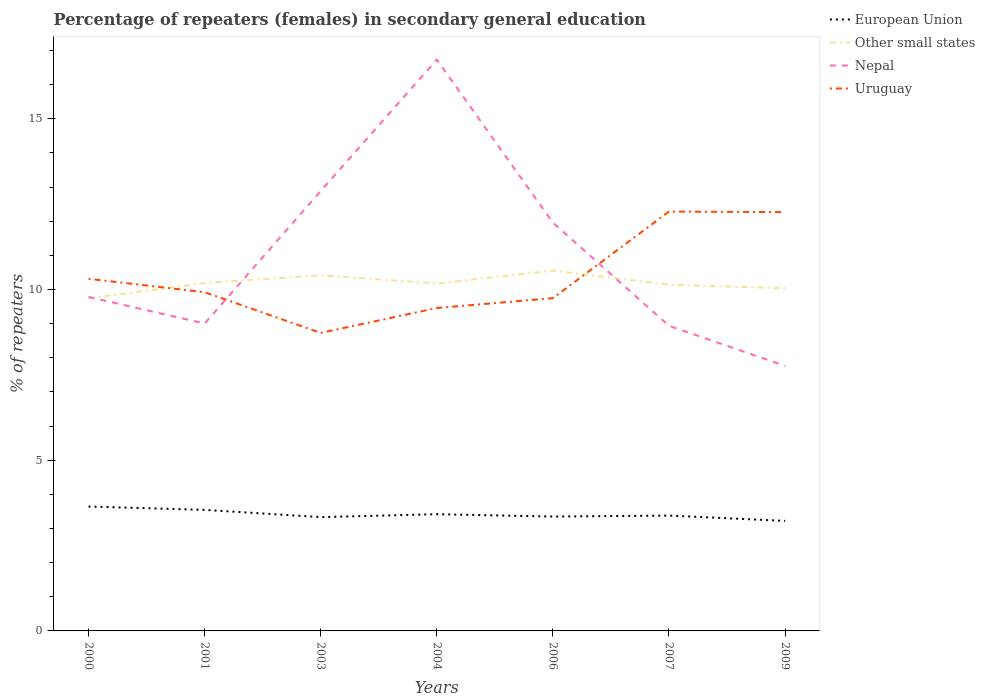Does the line corresponding to European Union intersect with the line corresponding to Nepal?
Make the answer very short. No. Across all years, what is the maximum percentage of female repeaters in European Union?
Offer a very short reply. 3.22. What is the total percentage of female repeaters in Other small states in the graph?
Your answer should be compact. 0.15. What is the difference between the highest and the second highest percentage of female repeaters in European Union?
Provide a short and direct response. 0.42. What is the difference between the highest and the lowest percentage of female repeaters in Uruguay?
Your response must be concise. 2. Is the percentage of female repeaters in Uruguay strictly greater than the percentage of female repeaters in Nepal over the years?
Make the answer very short. No. How many lines are there?
Give a very brief answer. 4. How many years are there in the graph?
Your response must be concise. 7. What is the difference between two consecutive major ticks on the Y-axis?
Give a very brief answer. 5. Are the values on the major ticks of Y-axis written in scientific E-notation?
Your answer should be very brief. No. Does the graph contain grids?
Offer a terse response. No. Where does the legend appear in the graph?
Ensure brevity in your answer.  Top right. How many legend labels are there?
Your response must be concise. 4. How are the legend labels stacked?
Your answer should be very brief. Vertical. What is the title of the graph?
Ensure brevity in your answer.  Percentage of repeaters (females) in secondary general education. Does "Czech Republic" appear as one of the legend labels in the graph?
Provide a short and direct response. No. What is the label or title of the X-axis?
Your answer should be compact. Years. What is the label or title of the Y-axis?
Your response must be concise. % of repeaters. What is the % of repeaters in European Union in 2000?
Make the answer very short. 3.64. What is the % of repeaters in Other small states in 2000?
Your answer should be very brief. 9.74. What is the % of repeaters of Nepal in 2000?
Make the answer very short. 9.78. What is the % of repeaters of Uruguay in 2000?
Offer a terse response. 10.31. What is the % of repeaters of European Union in 2001?
Your answer should be very brief. 3.55. What is the % of repeaters of Other small states in 2001?
Your answer should be very brief. 10.19. What is the % of repeaters in Nepal in 2001?
Your response must be concise. 9. What is the % of repeaters of Uruguay in 2001?
Your response must be concise. 9.92. What is the % of repeaters in European Union in 2003?
Give a very brief answer. 3.33. What is the % of repeaters in Other small states in 2003?
Offer a terse response. 10.42. What is the % of repeaters of Nepal in 2003?
Offer a terse response. 12.88. What is the % of repeaters in Uruguay in 2003?
Ensure brevity in your answer.  8.73. What is the % of repeaters of European Union in 2004?
Ensure brevity in your answer.  3.42. What is the % of repeaters of Other small states in 2004?
Give a very brief answer. 10.17. What is the % of repeaters of Nepal in 2004?
Offer a very short reply. 16.73. What is the % of repeaters in Uruguay in 2004?
Ensure brevity in your answer.  9.46. What is the % of repeaters in European Union in 2006?
Your answer should be compact. 3.35. What is the % of repeaters of Other small states in 2006?
Make the answer very short. 10.55. What is the % of repeaters of Nepal in 2006?
Your answer should be compact. 11.96. What is the % of repeaters in Uruguay in 2006?
Your response must be concise. 9.75. What is the % of repeaters of European Union in 2007?
Your response must be concise. 3.38. What is the % of repeaters of Other small states in 2007?
Make the answer very short. 10.14. What is the % of repeaters of Nepal in 2007?
Your response must be concise. 8.94. What is the % of repeaters of Uruguay in 2007?
Your answer should be very brief. 12.28. What is the % of repeaters of European Union in 2009?
Your answer should be very brief. 3.22. What is the % of repeaters in Other small states in 2009?
Keep it short and to the point. 10.03. What is the % of repeaters in Nepal in 2009?
Make the answer very short. 7.76. What is the % of repeaters of Uruguay in 2009?
Your response must be concise. 12.26. Across all years, what is the maximum % of repeaters in European Union?
Offer a terse response. 3.64. Across all years, what is the maximum % of repeaters in Other small states?
Offer a very short reply. 10.55. Across all years, what is the maximum % of repeaters in Nepal?
Give a very brief answer. 16.73. Across all years, what is the maximum % of repeaters in Uruguay?
Offer a terse response. 12.28. Across all years, what is the minimum % of repeaters of European Union?
Provide a succinct answer. 3.22. Across all years, what is the minimum % of repeaters in Other small states?
Provide a succinct answer. 9.74. Across all years, what is the minimum % of repeaters of Nepal?
Ensure brevity in your answer.  7.76. Across all years, what is the minimum % of repeaters in Uruguay?
Offer a terse response. 8.73. What is the total % of repeaters in European Union in the graph?
Ensure brevity in your answer.  23.89. What is the total % of repeaters in Other small states in the graph?
Offer a terse response. 71.24. What is the total % of repeaters of Nepal in the graph?
Make the answer very short. 77.05. What is the total % of repeaters of Uruguay in the graph?
Provide a succinct answer. 72.71. What is the difference between the % of repeaters in European Union in 2000 and that in 2001?
Offer a very short reply. 0.1. What is the difference between the % of repeaters in Other small states in 2000 and that in 2001?
Make the answer very short. -0.45. What is the difference between the % of repeaters of Nepal in 2000 and that in 2001?
Offer a terse response. 0.78. What is the difference between the % of repeaters of Uruguay in 2000 and that in 2001?
Keep it short and to the point. 0.39. What is the difference between the % of repeaters in European Union in 2000 and that in 2003?
Make the answer very short. 0.31. What is the difference between the % of repeaters of Other small states in 2000 and that in 2003?
Make the answer very short. -0.68. What is the difference between the % of repeaters of Nepal in 2000 and that in 2003?
Offer a very short reply. -3.1. What is the difference between the % of repeaters in Uruguay in 2000 and that in 2003?
Make the answer very short. 1.58. What is the difference between the % of repeaters of European Union in 2000 and that in 2004?
Offer a terse response. 0.22. What is the difference between the % of repeaters of Other small states in 2000 and that in 2004?
Keep it short and to the point. -0.43. What is the difference between the % of repeaters in Nepal in 2000 and that in 2004?
Give a very brief answer. -6.95. What is the difference between the % of repeaters of Uruguay in 2000 and that in 2004?
Give a very brief answer. 0.86. What is the difference between the % of repeaters in European Union in 2000 and that in 2006?
Your answer should be very brief. 0.29. What is the difference between the % of repeaters of Other small states in 2000 and that in 2006?
Offer a very short reply. -0.81. What is the difference between the % of repeaters in Nepal in 2000 and that in 2006?
Your answer should be compact. -2.17. What is the difference between the % of repeaters in Uruguay in 2000 and that in 2006?
Your response must be concise. 0.57. What is the difference between the % of repeaters of European Union in 2000 and that in 2007?
Provide a succinct answer. 0.26. What is the difference between the % of repeaters of Other small states in 2000 and that in 2007?
Give a very brief answer. -0.4. What is the difference between the % of repeaters of Nepal in 2000 and that in 2007?
Offer a very short reply. 0.85. What is the difference between the % of repeaters in Uruguay in 2000 and that in 2007?
Your response must be concise. -1.97. What is the difference between the % of repeaters in European Union in 2000 and that in 2009?
Offer a terse response. 0.42. What is the difference between the % of repeaters in Other small states in 2000 and that in 2009?
Keep it short and to the point. -0.3. What is the difference between the % of repeaters of Nepal in 2000 and that in 2009?
Give a very brief answer. 2.02. What is the difference between the % of repeaters of Uruguay in 2000 and that in 2009?
Your response must be concise. -1.95. What is the difference between the % of repeaters in European Union in 2001 and that in 2003?
Make the answer very short. 0.21. What is the difference between the % of repeaters in Other small states in 2001 and that in 2003?
Keep it short and to the point. -0.23. What is the difference between the % of repeaters in Nepal in 2001 and that in 2003?
Offer a very short reply. -3.88. What is the difference between the % of repeaters in Uruguay in 2001 and that in 2003?
Your answer should be very brief. 1.19. What is the difference between the % of repeaters of European Union in 2001 and that in 2004?
Keep it short and to the point. 0.13. What is the difference between the % of repeaters in Other small states in 2001 and that in 2004?
Your answer should be very brief. 0.02. What is the difference between the % of repeaters of Nepal in 2001 and that in 2004?
Provide a short and direct response. -7.73. What is the difference between the % of repeaters in Uruguay in 2001 and that in 2004?
Keep it short and to the point. 0.46. What is the difference between the % of repeaters in European Union in 2001 and that in 2006?
Make the answer very short. 0.2. What is the difference between the % of repeaters of Other small states in 2001 and that in 2006?
Offer a terse response. -0.36. What is the difference between the % of repeaters of Nepal in 2001 and that in 2006?
Make the answer very short. -2.95. What is the difference between the % of repeaters in Uruguay in 2001 and that in 2006?
Your answer should be compact. 0.17. What is the difference between the % of repeaters in European Union in 2001 and that in 2007?
Your answer should be very brief. 0.17. What is the difference between the % of repeaters of Other small states in 2001 and that in 2007?
Make the answer very short. 0.05. What is the difference between the % of repeaters of Nepal in 2001 and that in 2007?
Offer a terse response. 0.07. What is the difference between the % of repeaters of Uruguay in 2001 and that in 2007?
Ensure brevity in your answer.  -2.36. What is the difference between the % of repeaters in European Union in 2001 and that in 2009?
Make the answer very short. 0.32. What is the difference between the % of repeaters of Other small states in 2001 and that in 2009?
Give a very brief answer. 0.15. What is the difference between the % of repeaters of Nepal in 2001 and that in 2009?
Keep it short and to the point. 1.24. What is the difference between the % of repeaters in Uruguay in 2001 and that in 2009?
Offer a very short reply. -2.35. What is the difference between the % of repeaters of European Union in 2003 and that in 2004?
Keep it short and to the point. -0.09. What is the difference between the % of repeaters of Other small states in 2003 and that in 2004?
Make the answer very short. 0.24. What is the difference between the % of repeaters of Nepal in 2003 and that in 2004?
Give a very brief answer. -3.85. What is the difference between the % of repeaters of Uruguay in 2003 and that in 2004?
Provide a short and direct response. -0.73. What is the difference between the % of repeaters in European Union in 2003 and that in 2006?
Your answer should be compact. -0.02. What is the difference between the % of repeaters in Other small states in 2003 and that in 2006?
Give a very brief answer. -0.14. What is the difference between the % of repeaters in Nepal in 2003 and that in 2006?
Provide a short and direct response. 0.93. What is the difference between the % of repeaters of Uruguay in 2003 and that in 2006?
Offer a very short reply. -1.02. What is the difference between the % of repeaters of European Union in 2003 and that in 2007?
Make the answer very short. -0.05. What is the difference between the % of repeaters of Other small states in 2003 and that in 2007?
Provide a short and direct response. 0.27. What is the difference between the % of repeaters in Nepal in 2003 and that in 2007?
Offer a very short reply. 3.95. What is the difference between the % of repeaters of Uruguay in 2003 and that in 2007?
Make the answer very short. -3.55. What is the difference between the % of repeaters of European Union in 2003 and that in 2009?
Make the answer very short. 0.11. What is the difference between the % of repeaters in Other small states in 2003 and that in 2009?
Your answer should be very brief. 0.38. What is the difference between the % of repeaters of Nepal in 2003 and that in 2009?
Provide a short and direct response. 5.12. What is the difference between the % of repeaters of Uruguay in 2003 and that in 2009?
Ensure brevity in your answer.  -3.54. What is the difference between the % of repeaters of European Union in 2004 and that in 2006?
Your answer should be compact. 0.07. What is the difference between the % of repeaters in Other small states in 2004 and that in 2006?
Your answer should be compact. -0.38. What is the difference between the % of repeaters in Nepal in 2004 and that in 2006?
Your response must be concise. 4.77. What is the difference between the % of repeaters in Uruguay in 2004 and that in 2006?
Your response must be concise. -0.29. What is the difference between the % of repeaters in European Union in 2004 and that in 2007?
Your answer should be compact. 0.04. What is the difference between the % of repeaters of Other small states in 2004 and that in 2007?
Provide a succinct answer. 0.03. What is the difference between the % of repeaters of Nepal in 2004 and that in 2007?
Ensure brevity in your answer.  7.8. What is the difference between the % of repeaters in Uruguay in 2004 and that in 2007?
Your response must be concise. -2.83. What is the difference between the % of repeaters of European Union in 2004 and that in 2009?
Keep it short and to the point. 0.2. What is the difference between the % of repeaters of Other small states in 2004 and that in 2009?
Offer a terse response. 0.14. What is the difference between the % of repeaters in Nepal in 2004 and that in 2009?
Offer a terse response. 8.97. What is the difference between the % of repeaters of Uruguay in 2004 and that in 2009?
Your answer should be compact. -2.81. What is the difference between the % of repeaters of European Union in 2006 and that in 2007?
Your answer should be compact. -0.03. What is the difference between the % of repeaters in Other small states in 2006 and that in 2007?
Offer a terse response. 0.41. What is the difference between the % of repeaters in Nepal in 2006 and that in 2007?
Your response must be concise. 3.02. What is the difference between the % of repeaters of Uruguay in 2006 and that in 2007?
Your answer should be very brief. -2.54. What is the difference between the % of repeaters of European Union in 2006 and that in 2009?
Your answer should be compact. 0.13. What is the difference between the % of repeaters in Other small states in 2006 and that in 2009?
Provide a succinct answer. 0.52. What is the difference between the % of repeaters in Nepal in 2006 and that in 2009?
Make the answer very short. 4.2. What is the difference between the % of repeaters of Uruguay in 2006 and that in 2009?
Provide a short and direct response. -2.52. What is the difference between the % of repeaters of European Union in 2007 and that in 2009?
Provide a short and direct response. 0.16. What is the difference between the % of repeaters in Other small states in 2007 and that in 2009?
Keep it short and to the point. 0.11. What is the difference between the % of repeaters of Nepal in 2007 and that in 2009?
Give a very brief answer. 1.17. What is the difference between the % of repeaters of Uruguay in 2007 and that in 2009?
Offer a very short reply. 0.02. What is the difference between the % of repeaters in European Union in 2000 and the % of repeaters in Other small states in 2001?
Offer a very short reply. -6.55. What is the difference between the % of repeaters in European Union in 2000 and the % of repeaters in Nepal in 2001?
Offer a terse response. -5.36. What is the difference between the % of repeaters in European Union in 2000 and the % of repeaters in Uruguay in 2001?
Your answer should be very brief. -6.28. What is the difference between the % of repeaters of Other small states in 2000 and the % of repeaters of Nepal in 2001?
Keep it short and to the point. 0.74. What is the difference between the % of repeaters in Other small states in 2000 and the % of repeaters in Uruguay in 2001?
Offer a very short reply. -0.18. What is the difference between the % of repeaters in Nepal in 2000 and the % of repeaters in Uruguay in 2001?
Keep it short and to the point. -0.14. What is the difference between the % of repeaters of European Union in 2000 and the % of repeaters of Other small states in 2003?
Offer a terse response. -6.77. What is the difference between the % of repeaters in European Union in 2000 and the % of repeaters in Nepal in 2003?
Your response must be concise. -9.24. What is the difference between the % of repeaters in European Union in 2000 and the % of repeaters in Uruguay in 2003?
Ensure brevity in your answer.  -5.09. What is the difference between the % of repeaters in Other small states in 2000 and the % of repeaters in Nepal in 2003?
Give a very brief answer. -3.15. What is the difference between the % of repeaters of Other small states in 2000 and the % of repeaters of Uruguay in 2003?
Offer a terse response. 1.01. What is the difference between the % of repeaters in Nepal in 2000 and the % of repeaters in Uruguay in 2003?
Offer a terse response. 1.05. What is the difference between the % of repeaters in European Union in 2000 and the % of repeaters in Other small states in 2004?
Your response must be concise. -6.53. What is the difference between the % of repeaters in European Union in 2000 and the % of repeaters in Nepal in 2004?
Offer a terse response. -13.09. What is the difference between the % of repeaters of European Union in 2000 and the % of repeaters of Uruguay in 2004?
Your answer should be compact. -5.81. What is the difference between the % of repeaters in Other small states in 2000 and the % of repeaters in Nepal in 2004?
Offer a very short reply. -6.99. What is the difference between the % of repeaters of Other small states in 2000 and the % of repeaters of Uruguay in 2004?
Ensure brevity in your answer.  0.28. What is the difference between the % of repeaters of Nepal in 2000 and the % of repeaters of Uruguay in 2004?
Make the answer very short. 0.33. What is the difference between the % of repeaters of European Union in 2000 and the % of repeaters of Other small states in 2006?
Make the answer very short. -6.91. What is the difference between the % of repeaters of European Union in 2000 and the % of repeaters of Nepal in 2006?
Keep it short and to the point. -8.31. What is the difference between the % of repeaters in European Union in 2000 and the % of repeaters in Uruguay in 2006?
Your answer should be compact. -6.1. What is the difference between the % of repeaters in Other small states in 2000 and the % of repeaters in Nepal in 2006?
Offer a very short reply. -2.22. What is the difference between the % of repeaters of Other small states in 2000 and the % of repeaters of Uruguay in 2006?
Keep it short and to the point. -0.01. What is the difference between the % of repeaters in Nepal in 2000 and the % of repeaters in Uruguay in 2006?
Your response must be concise. 0.04. What is the difference between the % of repeaters of European Union in 2000 and the % of repeaters of Other small states in 2007?
Your answer should be compact. -6.5. What is the difference between the % of repeaters in European Union in 2000 and the % of repeaters in Nepal in 2007?
Keep it short and to the point. -5.29. What is the difference between the % of repeaters in European Union in 2000 and the % of repeaters in Uruguay in 2007?
Your response must be concise. -8.64. What is the difference between the % of repeaters of Other small states in 2000 and the % of repeaters of Nepal in 2007?
Provide a short and direct response. 0.8. What is the difference between the % of repeaters of Other small states in 2000 and the % of repeaters of Uruguay in 2007?
Make the answer very short. -2.54. What is the difference between the % of repeaters in Nepal in 2000 and the % of repeaters in Uruguay in 2007?
Give a very brief answer. -2.5. What is the difference between the % of repeaters of European Union in 2000 and the % of repeaters of Other small states in 2009?
Your answer should be compact. -6.39. What is the difference between the % of repeaters in European Union in 2000 and the % of repeaters in Nepal in 2009?
Give a very brief answer. -4.12. What is the difference between the % of repeaters in European Union in 2000 and the % of repeaters in Uruguay in 2009?
Keep it short and to the point. -8.62. What is the difference between the % of repeaters of Other small states in 2000 and the % of repeaters of Nepal in 2009?
Ensure brevity in your answer.  1.98. What is the difference between the % of repeaters in Other small states in 2000 and the % of repeaters in Uruguay in 2009?
Give a very brief answer. -2.53. What is the difference between the % of repeaters of Nepal in 2000 and the % of repeaters of Uruguay in 2009?
Provide a succinct answer. -2.48. What is the difference between the % of repeaters in European Union in 2001 and the % of repeaters in Other small states in 2003?
Offer a terse response. -6.87. What is the difference between the % of repeaters in European Union in 2001 and the % of repeaters in Nepal in 2003?
Provide a succinct answer. -9.34. What is the difference between the % of repeaters of European Union in 2001 and the % of repeaters of Uruguay in 2003?
Make the answer very short. -5.18. What is the difference between the % of repeaters of Other small states in 2001 and the % of repeaters of Nepal in 2003?
Your response must be concise. -2.7. What is the difference between the % of repeaters in Other small states in 2001 and the % of repeaters in Uruguay in 2003?
Keep it short and to the point. 1.46. What is the difference between the % of repeaters of Nepal in 2001 and the % of repeaters of Uruguay in 2003?
Offer a very short reply. 0.27. What is the difference between the % of repeaters of European Union in 2001 and the % of repeaters of Other small states in 2004?
Your response must be concise. -6.63. What is the difference between the % of repeaters in European Union in 2001 and the % of repeaters in Nepal in 2004?
Make the answer very short. -13.19. What is the difference between the % of repeaters of European Union in 2001 and the % of repeaters of Uruguay in 2004?
Give a very brief answer. -5.91. What is the difference between the % of repeaters in Other small states in 2001 and the % of repeaters in Nepal in 2004?
Provide a succinct answer. -6.54. What is the difference between the % of repeaters of Other small states in 2001 and the % of repeaters of Uruguay in 2004?
Your response must be concise. 0.73. What is the difference between the % of repeaters in Nepal in 2001 and the % of repeaters in Uruguay in 2004?
Offer a very short reply. -0.45. What is the difference between the % of repeaters in European Union in 2001 and the % of repeaters in Other small states in 2006?
Your answer should be very brief. -7.01. What is the difference between the % of repeaters in European Union in 2001 and the % of repeaters in Nepal in 2006?
Provide a succinct answer. -8.41. What is the difference between the % of repeaters in European Union in 2001 and the % of repeaters in Uruguay in 2006?
Ensure brevity in your answer.  -6.2. What is the difference between the % of repeaters of Other small states in 2001 and the % of repeaters of Nepal in 2006?
Keep it short and to the point. -1.77. What is the difference between the % of repeaters of Other small states in 2001 and the % of repeaters of Uruguay in 2006?
Your answer should be very brief. 0.44. What is the difference between the % of repeaters of Nepal in 2001 and the % of repeaters of Uruguay in 2006?
Keep it short and to the point. -0.74. What is the difference between the % of repeaters in European Union in 2001 and the % of repeaters in Other small states in 2007?
Provide a short and direct response. -6.6. What is the difference between the % of repeaters in European Union in 2001 and the % of repeaters in Nepal in 2007?
Ensure brevity in your answer.  -5.39. What is the difference between the % of repeaters of European Union in 2001 and the % of repeaters of Uruguay in 2007?
Your response must be concise. -8.74. What is the difference between the % of repeaters of Other small states in 2001 and the % of repeaters of Nepal in 2007?
Offer a very short reply. 1.25. What is the difference between the % of repeaters of Other small states in 2001 and the % of repeaters of Uruguay in 2007?
Your answer should be compact. -2.09. What is the difference between the % of repeaters in Nepal in 2001 and the % of repeaters in Uruguay in 2007?
Your answer should be very brief. -3.28. What is the difference between the % of repeaters of European Union in 2001 and the % of repeaters of Other small states in 2009?
Ensure brevity in your answer.  -6.49. What is the difference between the % of repeaters in European Union in 2001 and the % of repeaters in Nepal in 2009?
Your answer should be compact. -4.22. What is the difference between the % of repeaters in European Union in 2001 and the % of repeaters in Uruguay in 2009?
Ensure brevity in your answer.  -8.72. What is the difference between the % of repeaters of Other small states in 2001 and the % of repeaters of Nepal in 2009?
Provide a short and direct response. 2.43. What is the difference between the % of repeaters of Other small states in 2001 and the % of repeaters of Uruguay in 2009?
Keep it short and to the point. -2.08. What is the difference between the % of repeaters of Nepal in 2001 and the % of repeaters of Uruguay in 2009?
Offer a terse response. -3.26. What is the difference between the % of repeaters in European Union in 2003 and the % of repeaters in Other small states in 2004?
Your answer should be very brief. -6.84. What is the difference between the % of repeaters of European Union in 2003 and the % of repeaters of Nepal in 2004?
Give a very brief answer. -13.4. What is the difference between the % of repeaters of European Union in 2003 and the % of repeaters of Uruguay in 2004?
Give a very brief answer. -6.12. What is the difference between the % of repeaters in Other small states in 2003 and the % of repeaters in Nepal in 2004?
Provide a succinct answer. -6.32. What is the difference between the % of repeaters of Other small states in 2003 and the % of repeaters of Uruguay in 2004?
Offer a very short reply. 0.96. What is the difference between the % of repeaters of Nepal in 2003 and the % of repeaters of Uruguay in 2004?
Your answer should be very brief. 3.43. What is the difference between the % of repeaters in European Union in 2003 and the % of repeaters in Other small states in 2006?
Your answer should be very brief. -7.22. What is the difference between the % of repeaters in European Union in 2003 and the % of repeaters in Nepal in 2006?
Your answer should be very brief. -8.62. What is the difference between the % of repeaters in European Union in 2003 and the % of repeaters in Uruguay in 2006?
Ensure brevity in your answer.  -6.41. What is the difference between the % of repeaters in Other small states in 2003 and the % of repeaters in Nepal in 2006?
Your answer should be very brief. -1.54. What is the difference between the % of repeaters of Other small states in 2003 and the % of repeaters of Uruguay in 2006?
Your response must be concise. 0.67. What is the difference between the % of repeaters in Nepal in 2003 and the % of repeaters in Uruguay in 2006?
Your answer should be compact. 3.14. What is the difference between the % of repeaters in European Union in 2003 and the % of repeaters in Other small states in 2007?
Your response must be concise. -6.81. What is the difference between the % of repeaters in European Union in 2003 and the % of repeaters in Nepal in 2007?
Offer a terse response. -5.6. What is the difference between the % of repeaters in European Union in 2003 and the % of repeaters in Uruguay in 2007?
Keep it short and to the point. -8.95. What is the difference between the % of repeaters in Other small states in 2003 and the % of repeaters in Nepal in 2007?
Provide a short and direct response. 1.48. What is the difference between the % of repeaters in Other small states in 2003 and the % of repeaters in Uruguay in 2007?
Keep it short and to the point. -1.87. What is the difference between the % of repeaters of Nepal in 2003 and the % of repeaters of Uruguay in 2007?
Your answer should be compact. 0.6. What is the difference between the % of repeaters in European Union in 2003 and the % of repeaters in Other small states in 2009?
Your answer should be very brief. -6.7. What is the difference between the % of repeaters in European Union in 2003 and the % of repeaters in Nepal in 2009?
Offer a terse response. -4.43. What is the difference between the % of repeaters in European Union in 2003 and the % of repeaters in Uruguay in 2009?
Ensure brevity in your answer.  -8.93. What is the difference between the % of repeaters of Other small states in 2003 and the % of repeaters of Nepal in 2009?
Offer a terse response. 2.65. What is the difference between the % of repeaters of Other small states in 2003 and the % of repeaters of Uruguay in 2009?
Make the answer very short. -1.85. What is the difference between the % of repeaters of Nepal in 2003 and the % of repeaters of Uruguay in 2009?
Ensure brevity in your answer.  0.62. What is the difference between the % of repeaters in European Union in 2004 and the % of repeaters in Other small states in 2006?
Provide a short and direct response. -7.13. What is the difference between the % of repeaters of European Union in 2004 and the % of repeaters of Nepal in 2006?
Your answer should be compact. -8.54. What is the difference between the % of repeaters in European Union in 2004 and the % of repeaters in Uruguay in 2006?
Provide a succinct answer. -6.33. What is the difference between the % of repeaters in Other small states in 2004 and the % of repeaters in Nepal in 2006?
Make the answer very short. -1.78. What is the difference between the % of repeaters in Other small states in 2004 and the % of repeaters in Uruguay in 2006?
Make the answer very short. 0.43. What is the difference between the % of repeaters of Nepal in 2004 and the % of repeaters of Uruguay in 2006?
Your answer should be compact. 6.99. What is the difference between the % of repeaters in European Union in 2004 and the % of repeaters in Other small states in 2007?
Offer a terse response. -6.72. What is the difference between the % of repeaters in European Union in 2004 and the % of repeaters in Nepal in 2007?
Make the answer very short. -5.52. What is the difference between the % of repeaters of European Union in 2004 and the % of repeaters of Uruguay in 2007?
Provide a succinct answer. -8.86. What is the difference between the % of repeaters in Other small states in 2004 and the % of repeaters in Nepal in 2007?
Your answer should be very brief. 1.24. What is the difference between the % of repeaters in Other small states in 2004 and the % of repeaters in Uruguay in 2007?
Ensure brevity in your answer.  -2.11. What is the difference between the % of repeaters in Nepal in 2004 and the % of repeaters in Uruguay in 2007?
Your response must be concise. 4.45. What is the difference between the % of repeaters of European Union in 2004 and the % of repeaters of Other small states in 2009?
Your answer should be very brief. -6.62. What is the difference between the % of repeaters of European Union in 2004 and the % of repeaters of Nepal in 2009?
Offer a very short reply. -4.34. What is the difference between the % of repeaters of European Union in 2004 and the % of repeaters of Uruguay in 2009?
Offer a terse response. -8.85. What is the difference between the % of repeaters in Other small states in 2004 and the % of repeaters in Nepal in 2009?
Give a very brief answer. 2.41. What is the difference between the % of repeaters in Other small states in 2004 and the % of repeaters in Uruguay in 2009?
Give a very brief answer. -2.09. What is the difference between the % of repeaters of Nepal in 2004 and the % of repeaters of Uruguay in 2009?
Provide a succinct answer. 4.47. What is the difference between the % of repeaters in European Union in 2006 and the % of repeaters in Other small states in 2007?
Offer a very short reply. -6.79. What is the difference between the % of repeaters in European Union in 2006 and the % of repeaters in Nepal in 2007?
Make the answer very short. -5.59. What is the difference between the % of repeaters in European Union in 2006 and the % of repeaters in Uruguay in 2007?
Provide a succinct answer. -8.93. What is the difference between the % of repeaters of Other small states in 2006 and the % of repeaters of Nepal in 2007?
Your response must be concise. 1.62. What is the difference between the % of repeaters in Other small states in 2006 and the % of repeaters in Uruguay in 2007?
Your answer should be very brief. -1.73. What is the difference between the % of repeaters of Nepal in 2006 and the % of repeaters of Uruguay in 2007?
Make the answer very short. -0.33. What is the difference between the % of repeaters in European Union in 2006 and the % of repeaters in Other small states in 2009?
Make the answer very short. -6.69. What is the difference between the % of repeaters of European Union in 2006 and the % of repeaters of Nepal in 2009?
Offer a terse response. -4.41. What is the difference between the % of repeaters in European Union in 2006 and the % of repeaters in Uruguay in 2009?
Your answer should be compact. -8.92. What is the difference between the % of repeaters of Other small states in 2006 and the % of repeaters of Nepal in 2009?
Your answer should be very brief. 2.79. What is the difference between the % of repeaters of Other small states in 2006 and the % of repeaters of Uruguay in 2009?
Offer a terse response. -1.71. What is the difference between the % of repeaters of Nepal in 2006 and the % of repeaters of Uruguay in 2009?
Offer a terse response. -0.31. What is the difference between the % of repeaters in European Union in 2007 and the % of repeaters in Other small states in 2009?
Offer a terse response. -6.66. What is the difference between the % of repeaters in European Union in 2007 and the % of repeaters in Nepal in 2009?
Offer a very short reply. -4.38. What is the difference between the % of repeaters of European Union in 2007 and the % of repeaters of Uruguay in 2009?
Provide a succinct answer. -8.89. What is the difference between the % of repeaters of Other small states in 2007 and the % of repeaters of Nepal in 2009?
Offer a very short reply. 2.38. What is the difference between the % of repeaters of Other small states in 2007 and the % of repeaters of Uruguay in 2009?
Ensure brevity in your answer.  -2.12. What is the difference between the % of repeaters in Nepal in 2007 and the % of repeaters in Uruguay in 2009?
Offer a very short reply. -3.33. What is the average % of repeaters in European Union per year?
Ensure brevity in your answer.  3.41. What is the average % of repeaters of Other small states per year?
Your answer should be compact. 10.18. What is the average % of repeaters in Nepal per year?
Make the answer very short. 11.01. What is the average % of repeaters in Uruguay per year?
Offer a very short reply. 10.39. In the year 2000, what is the difference between the % of repeaters in European Union and % of repeaters in Other small states?
Your answer should be very brief. -6.1. In the year 2000, what is the difference between the % of repeaters in European Union and % of repeaters in Nepal?
Your answer should be very brief. -6.14. In the year 2000, what is the difference between the % of repeaters of European Union and % of repeaters of Uruguay?
Make the answer very short. -6.67. In the year 2000, what is the difference between the % of repeaters of Other small states and % of repeaters of Nepal?
Your response must be concise. -0.04. In the year 2000, what is the difference between the % of repeaters in Other small states and % of repeaters in Uruguay?
Ensure brevity in your answer.  -0.57. In the year 2000, what is the difference between the % of repeaters of Nepal and % of repeaters of Uruguay?
Ensure brevity in your answer.  -0.53. In the year 2001, what is the difference between the % of repeaters in European Union and % of repeaters in Other small states?
Provide a succinct answer. -6.64. In the year 2001, what is the difference between the % of repeaters of European Union and % of repeaters of Nepal?
Your response must be concise. -5.46. In the year 2001, what is the difference between the % of repeaters in European Union and % of repeaters in Uruguay?
Give a very brief answer. -6.37. In the year 2001, what is the difference between the % of repeaters in Other small states and % of repeaters in Nepal?
Your response must be concise. 1.19. In the year 2001, what is the difference between the % of repeaters in Other small states and % of repeaters in Uruguay?
Provide a succinct answer. 0.27. In the year 2001, what is the difference between the % of repeaters in Nepal and % of repeaters in Uruguay?
Provide a succinct answer. -0.92. In the year 2003, what is the difference between the % of repeaters in European Union and % of repeaters in Other small states?
Your answer should be compact. -7.08. In the year 2003, what is the difference between the % of repeaters of European Union and % of repeaters of Nepal?
Give a very brief answer. -9.55. In the year 2003, what is the difference between the % of repeaters in European Union and % of repeaters in Uruguay?
Give a very brief answer. -5.4. In the year 2003, what is the difference between the % of repeaters in Other small states and % of repeaters in Nepal?
Offer a terse response. -2.47. In the year 2003, what is the difference between the % of repeaters of Other small states and % of repeaters of Uruguay?
Offer a terse response. 1.69. In the year 2003, what is the difference between the % of repeaters of Nepal and % of repeaters of Uruguay?
Offer a terse response. 4.16. In the year 2004, what is the difference between the % of repeaters in European Union and % of repeaters in Other small states?
Your answer should be very brief. -6.75. In the year 2004, what is the difference between the % of repeaters in European Union and % of repeaters in Nepal?
Your response must be concise. -13.31. In the year 2004, what is the difference between the % of repeaters of European Union and % of repeaters of Uruguay?
Your answer should be compact. -6.04. In the year 2004, what is the difference between the % of repeaters in Other small states and % of repeaters in Nepal?
Your response must be concise. -6.56. In the year 2004, what is the difference between the % of repeaters of Other small states and % of repeaters of Uruguay?
Provide a succinct answer. 0.72. In the year 2004, what is the difference between the % of repeaters in Nepal and % of repeaters in Uruguay?
Provide a short and direct response. 7.27. In the year 2006, what is the difference between the % of repeaters of European Union and % of repeaters of Other small states?
Offer a terse response. -7.2. In the year 2006, what is the difference between the % of repeaters in European Union and % of repeaters in Nepal?
Your response must be concise. -8.61. In the year 2006, what is the difference between the % of repeaters in European Union and % of repeaters in Uruguay?
Your answer should be compact. -6.4. In the year 2006, what is the difference between the % of repeaters in Other small states and % of repeaters in Nepal?
Ensure brevity in your answer.  -1.41. In the year 2006, what is the difference between the % of repeaters of Other small states and % of repeaters of Uruguay?
Keep it short and to the point. 0.81. In the year 2006, what is the difference between the % of repeaters of Nepal and % of repeaters of Uruguay?
Provide a short and direct response. 2.21. In the year 2007, what is the difference between the % of repeaters of European Union and % of repeaters of Other small states?
Provide a succinct answer. -6.76. In the year 2007, what is the difference between the % of repeaters of European Union and % of repeaters of Nepal?
Give a very brief answer. -5.56. In the year 2007, what is the difference between the % of repeaters of European Union and % of repeaters of Uruguay?
Your answer should be compact. -8.9. In the year 2007, what is the difference between the % of repeaters of Other small states and % of repeaters of Nepal?
Your response must be concise. 1.21. In the year 2007, what is the difference between the % of repeaters in Other small states and % of repeaters in Uruguay?
Offer a very short reply. -2.14. In the year 2007, what is the difference between the % of repeaters of Nepal and % of repeaters of Uruguay?
Give a very brief answer. -3.35. In the year 2009, what is the difference between the % of repeaters of European Union and % of repeaters of Other small states?
Provide a succinct answer. -6.81. In the year 2009, what is the difference between the % of repeaters of European Union and % of repeaters of Nepal?
Make the answer very short. -4.54. In the year 2009, what is the difference between the % of repeaters of European Union and % of repeaters of Uruguay?
Offer a very short reply. -9.04. In the year 2009, what is the difference between the % of repeaters of Other small states and % of repeaters of Nepal?
Offer a very short reply. 2.27. In the year 2009, what is the difference between the % of repeaters in Other small states and % of repeaters in Uruguay?
Your response must be concise. -2.23. In the year 2009, what is the difference between the % of repeaters in Nepal and % of repeaters in Uruguay?
Ensure brevity in your answer.  -4.5. What is the ratio of the % of repeaters in European Union in 2000 to that in 2001?
Provide a short and direct response. 1.03. What is the ratio of the % of repeaters of Other small states in 2000 to that in 2001?
Provide a short and direct response. 0.96. What is the ratio of the % of repeaters in Nepal in 2000 to that in 2001?
Provide a succinct answer. 1.09. What is the ratio of the % of repeaters in Uruguay in 2000 to that in 2001?
Offer a very short reply. 1.04. What is the ratio of the % of repeaters in European Union in 2000 to that in 2003?
Give a very brief answer. 1.09. What is the ratio of the % of repeaters in Other small states in 2000 to that in 2003?
Give a very brief answer. 0.94. What is the ratio of the % of repeaters of Nepal in 2000 to that in 2003?
Offer a terse response. 0.76. What is the ratio of the % of repeaters in Uruguay in 2000 to that in 2003?
Ensure brevity in your answer.  1.18. What is the ratio of the % of repeaters in European Union in 2000 to that in 2004?
Your response must be concise. 1.07. What is the ratio of the % of repeaters of Other small states in 2000 to that in 2004?
Your answer should be compact. 0.96. What is the ratio of the % of repeaters in Nepal in 2000 to that in 2004?
Give a very brief answer. 0.58. What is the ratio of the % of repeaters of Uruguay in 2000 to that in 2004?
Your response must be concise. 1.09. What is the ratio of the % of repeaters of European Union in 2000 to that in 2006?
Provide a succinct answer. 1.09. What is the ratio of the % of repeaters in Other small states in 2000 to that in 2006?
Make the answer very short. 0.92. What is the ratio of the % of repeaters of Nepal in 2000 to that in 2006?
Your answer should be compact. 0.82. What is the ratio of the % of repeaters of Uruguay in 2000 to that in 2006?
Keep it short and to the point. 1.06. What is the ratio of the % of repeaters in European Union in 2000 to that in 2007?
Offer a terse response. 1.08. What is the ratio of the % of repeaters of Other small states in 2000 to that in 2007?
Give a very brief answer. 0.96. What is the ratio of the % of repeaters in Nepal in 2000 to that in 2007?
Provide a succinct answer. 1.09. What is the ratio of the % of repeaters of Uruguay in 2000 to that in 2007?
Your answer should be very brief. 0.84. What is the ratio of the % of repeaters in European Union in 2000 to that in 2009?
Provide a short and direct response. 1.13. What is the ratio of the % of repeaters of Other small states in 2000 to that in 2009?
Offer a terse response. 0.97. What is the ratio of the % of repeaters in Nepal in 2000 to that in 2009?
Give a very brief answer. 1.26. What is the ratio of the % of repeaters of Uruguay in 2000 to that in 2009?
Provide a succinct answer. 0.84. What is the ratio of the % of repeaters in European Union in 2001 to that in 2003?
Your answer should be very brief. 1.06. What is the ratio of the % of repeaters in Other small states in 2001 to that in 2003?
Provide a short and direct response. 0.98. What is the ratio of the % of repeaters of Nepal in 2001 to that in 2003?
Your answer should be compact. 0.7. What is the ratio of the % of repeaters in Uruguay in 2001 to that in 2003?
Offer a terse response. 1.14. What is the ratio of the % of repeaters of European Union in 2001 to that in 2004?
Provide a short and direct response. 1.04. What is the ratio of the % of repeaters in Other small states in 2001 to that in 2004?
Your response must be concise. 1. What is the ratio of the % of repeaters of Nepal in 2001 to that in 2004?
Give a very brief answer. 0.54. What is the ratio of the % of repeaters of Uruguay in 2001 to that in 2004?
Provide a succinct answer. 1.05. What is the ratio of the % of repeaters in European Union in 2001 to that in 2006?
Offer a very short reply. 1.06. What is the ratio of the % of repeaters in Other small states in 2001 to that in 2006?
Offer a very short reply. 0.97. What is the ratio of the % of repeaters in Nepal in 2001 to that in 2006?
Provide a succinct answer. 0.75. What is the ratio of the % of repeaters of Uruguay in 2001 to that in 2006?
Provide a succinct answer. 1.02. What is the ratio of the % of repeaters of European Union in 2001 to that in 2007?
Keep it short and to the point. 1.05. What is the ratio of the % of repeaters in Other small states in 2001 to that in 2007?
Offer a terse response. 1. What is the ratio of the % of repeaters of Nepal in 2001 to that in 2007?
Offer a very short reply. 1.01. What is the ratio of the % of repeaters of Uruguay in 2001 to that in 2007?
Give a very brief answer. 0.81. What is the ratio of the % of repeaters in European Union in 2001 to that in 2009?
Provide a short and direct response. 1.1. What is the ratio of the % of repeaters of Other small states in 2001 to that in 2009?
Your response must be concise. 1.02. What is the ratio of the % of repeaters in Nepal in 2001 to that in 2009?
Keep it short and to the point. 1.16. What is the ratio of the % of repeaters in Uruguay in 2001 to that in 2009?
Give a very brief answer. 0.81. What is the ratio of the % of repeaters of European Union in 2003 to that in 2004?
Keep it short and to the point. 0.97. What is the ratio of the % of repeaters of Other small states in 2003 to that in 2004?
Make the answer very short. 1.02. What is the ratio of the % of repeaters in Nepal in 2003 to that in 2004?
Your response must be concise. 0.77. What is the ratio of the % of repeaters of Uruguay in 2003 to that in 2004?
Your answer should be very brief. 0.92. What is the ratio of the % of repeaters in European Union in 2003 to that in 2006?
Offer a terse response. 1. What is the ratio of the % of repeaters in Other small states in 2003 to that in 2006?
Offer a terse response. 0.99. What is the ratio of the % of repeaters of Nepal in 2003 to that in 2006?
Keep it short and to the point. 1.08. What is the ratio of the % of repeaters in Uruguay in 2003 to that in 2006?
Your response must be concise. 0.9. What is the ratio of the % of repeaters in European Union in 2003 to that in 2007?
Provide a short and direct response. 0.99. What is the ratio of the % of repeaters of Other small states in 2003 to that in 2007?
Make the answer very short. 1.03. What is the ratio of the % of repeaters of Nepal in 2003 to that in 2007?
Offer a terse response. 1.44. What is the ratio of the % of repeaters of Uruguay in 2003 to that in 2007?
Your response must be concise. 0.71. What is the ratio of the % of repeaters of European Union in 2003 to that in 2009?
Your answer should be very brief. 1.03. What is the ratio of the % of repeaters in Other small states in 2003 to that in 2009?
Provide a short and direct response. 1.04. What is the ratio of the % of repeaters of Nepal in 2003 to that in 2009?
Your answer should be very brief. 1.66. What is the ratio of the % of repeaters of Uruguay in 2003 to that in 2009?
Provide a succinct answer. 0.71. What is the ratio of the % of repeaters in European Union in 2004 to that in 2006?
Make the answer very short. 1.02. What is the ratio of the % of repeaters of Other small states in 2004 to that in 2006?
Provide a short and direct response. 0.96. What is the ratio of the % of repeaters in Nepal in 2004 to that in 2006?
Make the answer very short. 1.4. What is the ratio of the % of repeaters in Uruguay in 2004 to that in 2006?
Ensure brevity in your answer.  0.97. What is the ratio of the % of repeaters in European Union in 2004 to that in 2007?
Ensure brevity in your answer.  1.01. What is the ratio of the % of repeaters in Nepal in 2004 to that in 2007?
Your response must be concise. 1.87. What is the ratio of the % of repeaters of Uruguay in 2004 to that in 2007?
Your answer should be very brief. 0.77. What is the ratio of the % of repeaters of European Union in 2004 to that in 2009?
Your answer should be very brief. 1.06. What is the ratio of the % of repeaters of Other small states in 2004 to that in 2009?
Your answer should be compact. 1.01. What is the ratio of the % of repeaters in Nepal in 2004 to that in 2009?
Give a very brief answer. 2.16. What is the ratio of the % of repeaters in Uruguay in 2004 to that in 2009?
Your answer should be compact. 0.77. What is the ratio of the % of repeaters of European Union in 2006 to that in 2007?
Make the answer very short. 0.99. What is the ratio of the % of repeaters of Other small states in 2006 to that in 2007?
Make the answer very short. 1.04. What is the ratio of the % of repeaters in Nepal in 2006 to that in 2007?
Provide a succinct answer. 1.34. What is the ratio of the % of repeaters of Uruguay in 2006 to that in 2007?
Ensure brevity in your answer.  0.79. What is the ratio of the % of repeaters of European Union in 2006 to that in 2009?
Offer a very short reply. 1.04. What is the ratio of the % of repeaters of Other small states in 2006 to that in 2009?
Keep it short and to the point. 1.05. What is the ratio of the % of repeaters of Nepal in 2006 to that in 2009?
Offer a very short reply. 1.54. What is the ratio of the % of repeaters of Uruguay in 2006 to that in 2009?
Ensure brevity in your answer.  0.79. What is the ratio of the % of repeaters in European Union in 2007 to that in 2009?
Offer a very short reply. 1.05. What is the ratio of the % of repeaters of Other small states in 2007 to that in 2009?
Provide a short and direct response. 1.01. What is the ratio of the % of repeaters of Nepal in 2007 to that in 2009?
Keep it short and to the point. 1.15. What is the difference between the highest and the second highest % of repeaters of European Union?
Ensure brevity in your answer.  0.1. What is the difference between the highest and the second highest % of repeaters of Other small states?
Offer a terse response. 0.14. What is the difference between the highest and the second highest % of repeaters of Nepal?
Your answer should be very brief. 3.85. What is the difference between the highest and the second highest % of repeaters in Uruguay?
Your answer should be compact. 0.02. What is the difference between the highest and the lowest % of repeaters in European Union?
Offer a very short reply. 0.42. What is the difference between the highest and the lowest % of repeaters of Other small states?
Your answer should be very brief. 0.81. What is the difference between the highest and the lowest % of repeaters of Nepal?
Provide a short and direct response. 8.97. What is the difference between the highest and the lowest % of repeaters of Uruguay?
Offer a terse response. 3.55. 